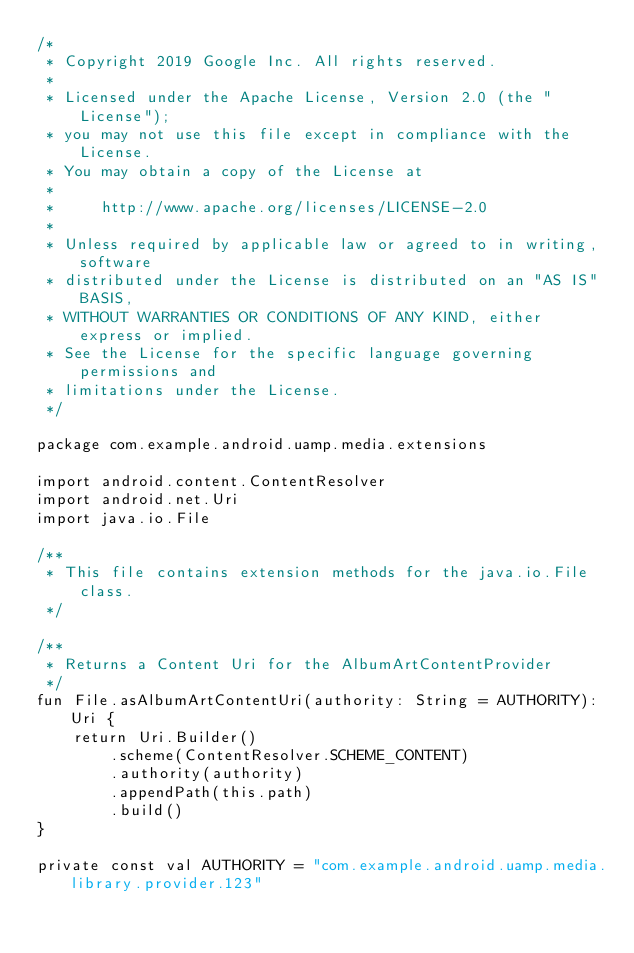Convert code to text. <code><loc_0><loc_0><loc_500><loc_500><_Kotlin_>/*
 * Copyright 2019 Google Inc. All rights reserved.
 *
 * Licensed under the Apache License, Version 2.0 (the "License");
 * you may not use this file except in compliance with the License.
 * You may obtain a copy of the License at
 *
 *     http://www.apache.org/licenses/LICENSE-2.0
 *
 * Unless required by applicable law or agreed to in writing, software
 * distributed under the License is distributed on an "AS IS" BASIS,
 * WITHOUT WARRANTIES OR CONDITIONS OF ANY KIND, either express or implied.
 * See the License for the specific language governing permissions and
 * limitations under the License.
 */

package com.example.android.uamp.media.extensions

import android.content.ContentResolver
import android.net.Uri
import java.io.File

/**
 * This file contains extension methods for the java.io.File class.
 */

/**
 * Returns a Content Uri for the AlbumArtContentProvider
 */
fun File.asAlbumArtContentUri(authority: String = AUTHORITY): Uri {
    return Uri.Builder()
        .scheme(ContentResolver.SCHEME_CONTENT)
        .authority(authority)
        .appendPath(this.path)
        .build()
}

private const val AUTHORITY = "com.example.android.uamp.media.library.provider.123"
</code> 